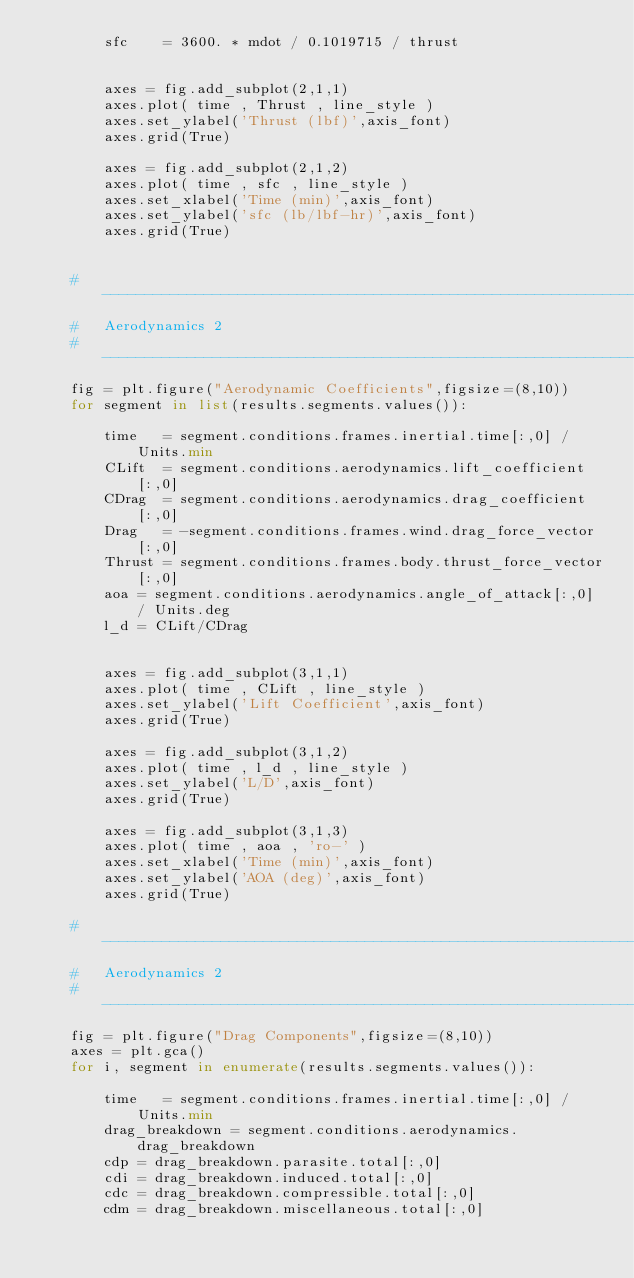<code> <loc_0><loc_0><loc_500><loc_500><_Python_>        sfc    = 3600. * mdot / 0.1019715 / thrust


        axes = fig.add_subplot(2,1,1)
        axes.plot( time , Thrust , line_style )
        axes.set_ylabel('Thrust (lbf)',axis_font)
        axes.grid(True)

        axes = fig.add_subplot(2,1,2)
        axes.plot( time , sfc , line_style )
        axes.set_xlabel('Time (min)',axis_font)
        axes.set_ylabel('sfc (lb/lbf-hr)',axis_font)
        axes.grid(True)


    # ------------------------------------------------------------------
    #   Aerodynamics 2
    # ------------------------------------------------------------------
    fig = plt.figure("Aerodynamic Coefficients",figsize=(8,10))
    for segment in list(results.segments.values()):

        time   = segment.conditions.frames.inertial.time[:,0] / Units.min
        CLift  = segment.conditions.aerodynamics.lift_coefficient[:,0]
        CDrag  = segment.conditions.aerodynamics.drag_coefficient[:,0]
        Drag   = -segment.conditions.frames.wind.drag_force_vector[:,0]
        Thrust = segment.conditions.frames.body.thrust_force_vector[:,0]
        aoa = segment.conditions.aerodynamics.angle_of_attack[:,0] / Units.deg
        l_d = CLift/CDrag


        axes = fig.add_subplot(3,1,1)
        axes.plot( time , CLift , line_style )
        axes.set_ylabel('Lift Coefficient',axis_font)
        axes.grid(True)

        axes = fig.add_subplot(3,1,2)
        axes.plot( time , l_d , line_style )
        axes.set_ylabel('L/D',axis_font)
        axes.grid(True)

        axes = fig.add_subplot(3,1,3)
        axes.plot( time , aoa , 'ro-' )
        axes.set_xlabel('Time (min)',axis_font)
        axes.set_ylabel('AOA (deg)',axis_font)
        axes.grid(True)

    # ------------------------------------------------------------------
    #   Aerodynamics 2
    # ------------------------------------------------------------------
    fig = plt.figure("Drag Components",figsize=(8,10))
    axes = plt.gca()
    for i, segment in enumerate(results.segments.values()):

        time   = segment.conditions.frames.inertial.time[:,0] / Units.min
        drag_breakdown = segment.conditions.aerodynamics.drag_breakdown
        cdp = drag_breakdown.parasite.total[:,0]
        cdi = drag_breakdown.induced.total[:,0]
        cdc = drag_breakdown.compressible.total[:,0]
        cdm = drag_breakdown.miscellaneous.total[:,0]</code> 